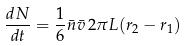<formula> <loc_0><loc_0><loc_500><loc_500>\frac { d N } { d t } = \frac { 1 } { 6 } \bar { n } \bar { v } \, 2 \pi L ( r _ { 2 } - r _ { 1 } )</formula> 